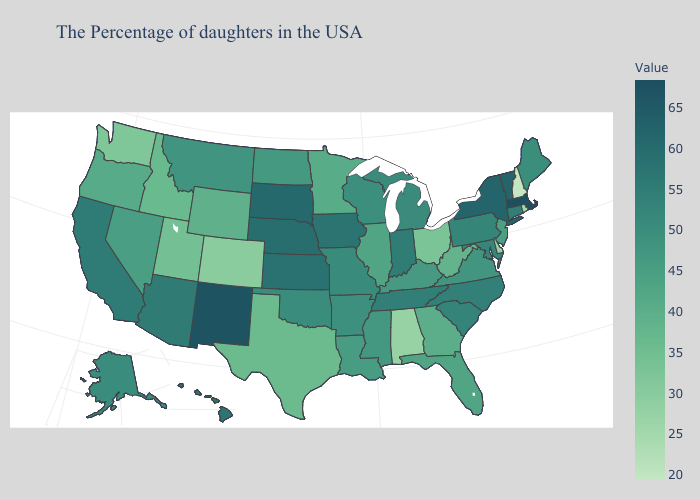Which states have the lowest value in the South?
Give a very brief answer. Alabama. Does California have a higher value than Kentucky?
Quick response, please. Yes. Does New Mexico have the highest value in the West?
Give a very brief answer. Yes. Does Wisconsin have the highest value in the MidWest?
Quick response, please. No. Among the states that border Nevada , which have the lowest value?
Quick response, please. Utah. Does Illinois have the lowest value in the USA?
Concise answer only. No. 